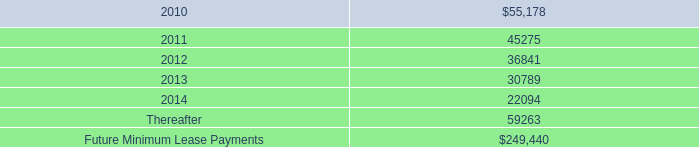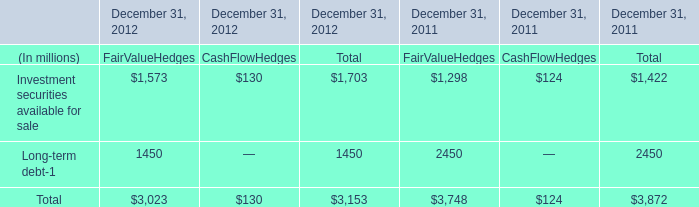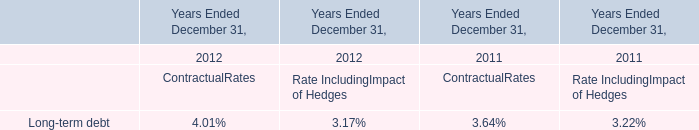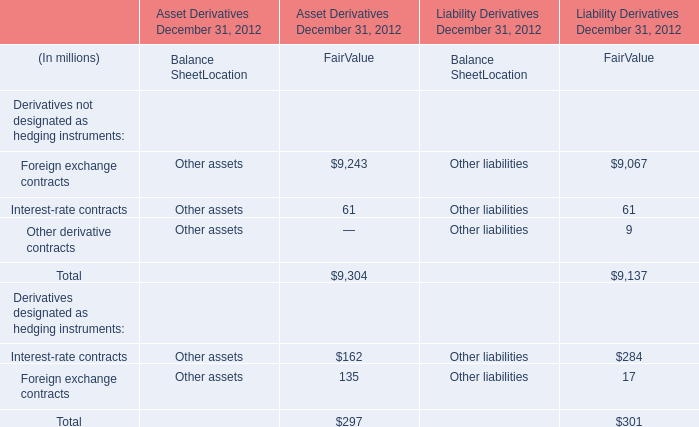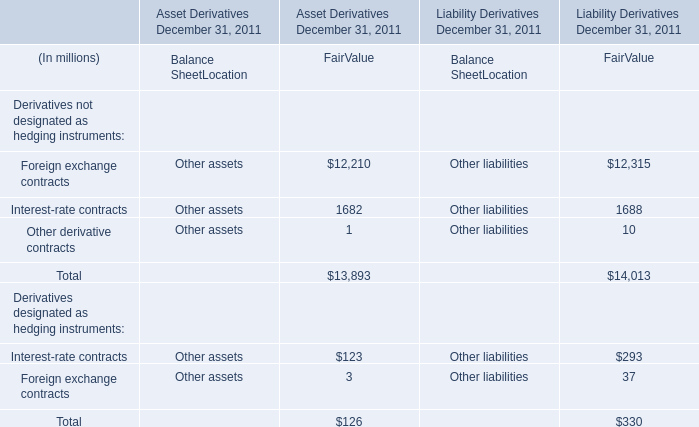What's the total amount of the Long-term debt in the years where Investment securities available for sale greater than 0? (in million) 
Computations: (1450 + 2450)
Answer: 3900.0. 